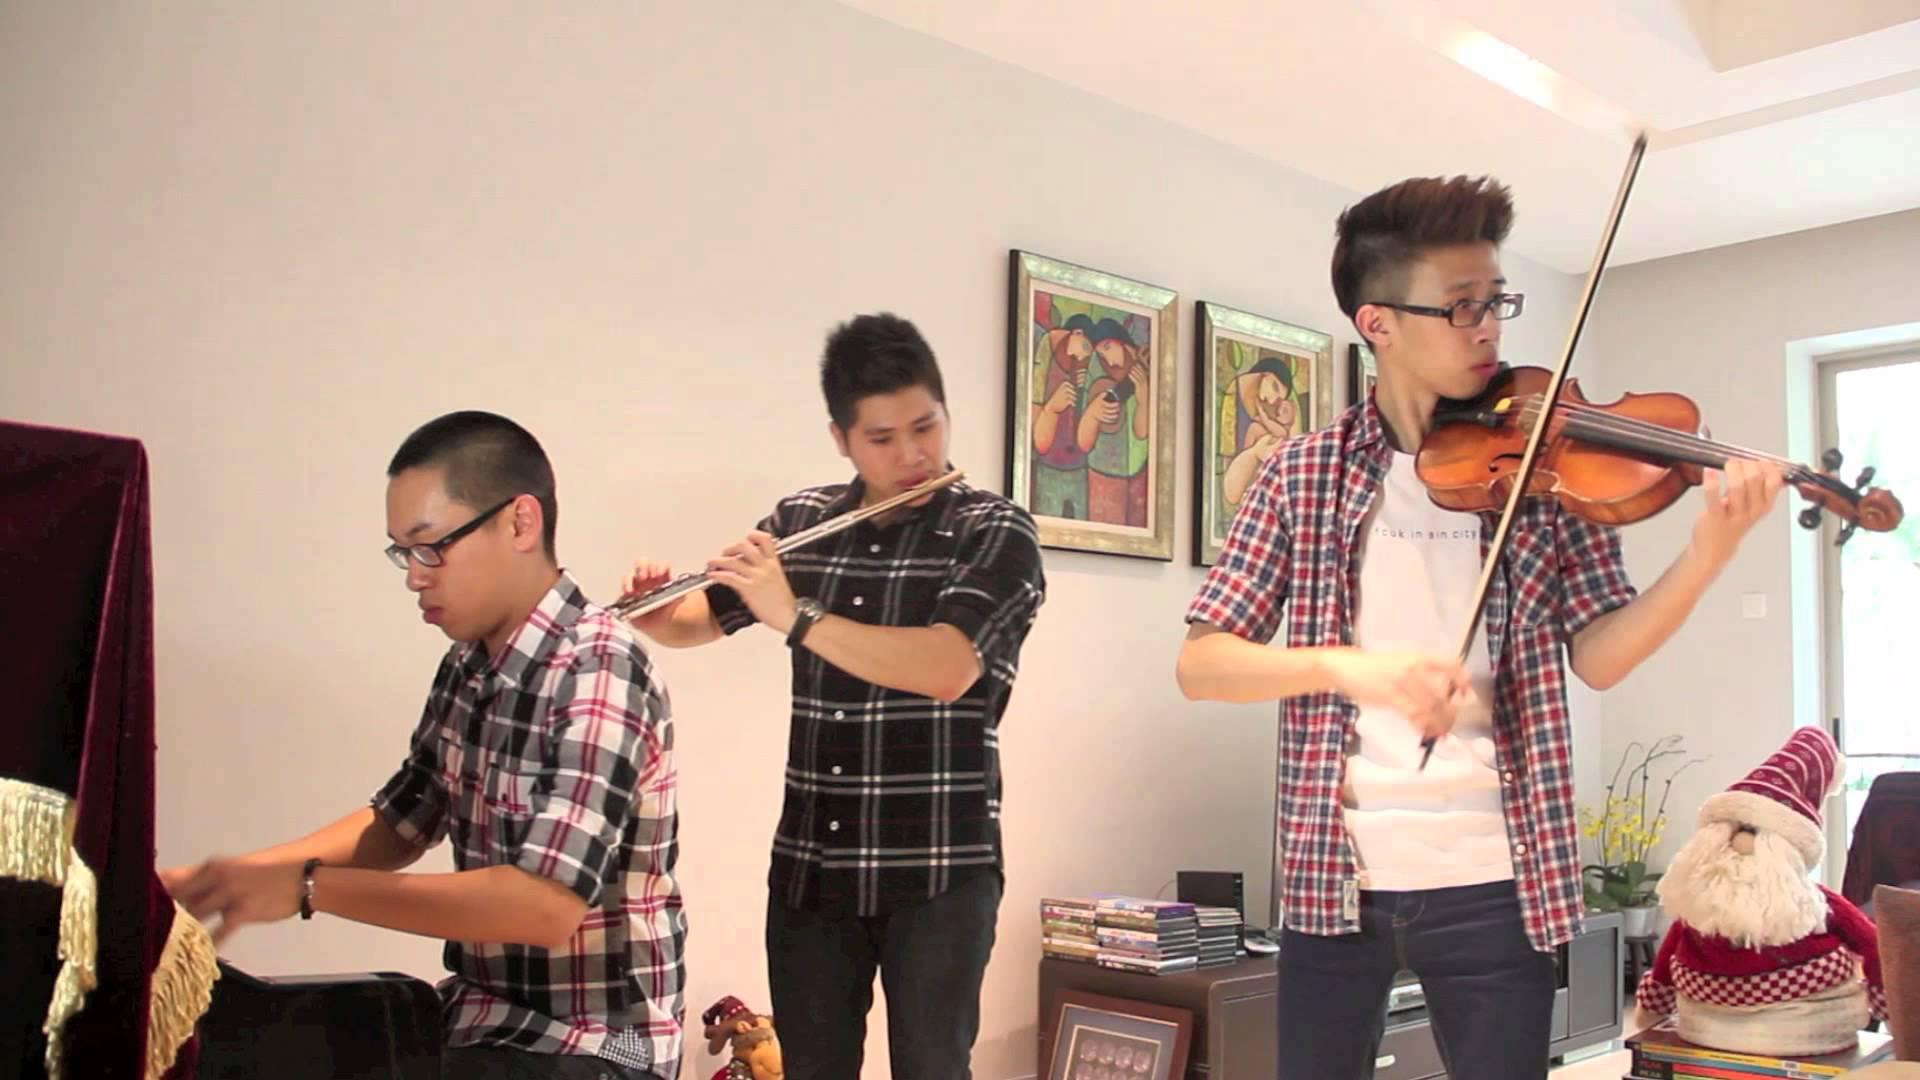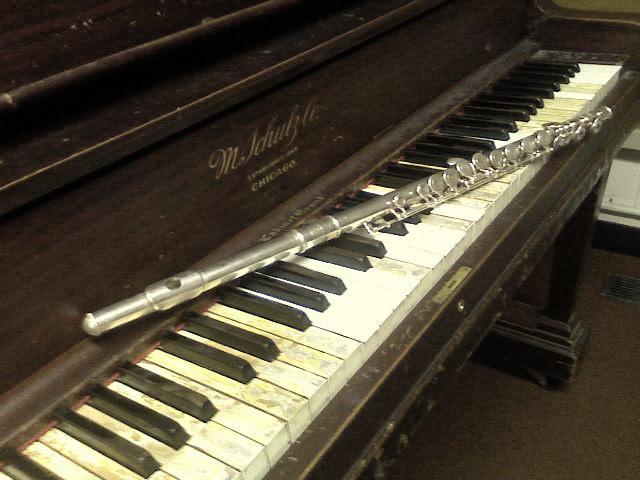The first image is the image on the left, the second image is the image on the right. For the images displayed, is the sentence "An image shows one silver wind instrument laid at an angle across the keys of a brown wood-grain piano that faces rightward." factually correct? Answer yes or no. Yes. The first image is the image on the left, the second image is the image on the right. Evaluate the accuracy of this statement regarding the images: "There is exactly one flute resting on piano keys.". Is it true? Answer yes or no. Yes. 